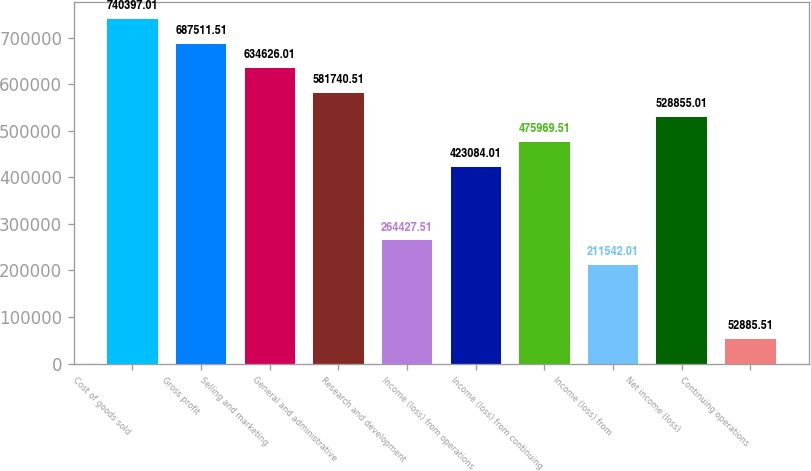<chart> <loc_0><loc_0><loc_500><loc_500><bar_chart><fcel>Cost of goods sold<fcel>Gross profit<fcel>Selling and marketing<fcel>General and administrative<fcel>Research and development<fcel>Income (loss) from operations<fcel>Income (loss) from continuing<fcel>Income (loss) from<fcel>Net income (loss)<fcel>Continuing operations<nl><fcel>740397<fcel>687512<fcel>634626<fcel>581741<fcel>264428<fcel>423084<fcel>475970<fcel>211542<fcel>528855<fcel>52885.5<nl></chart> 